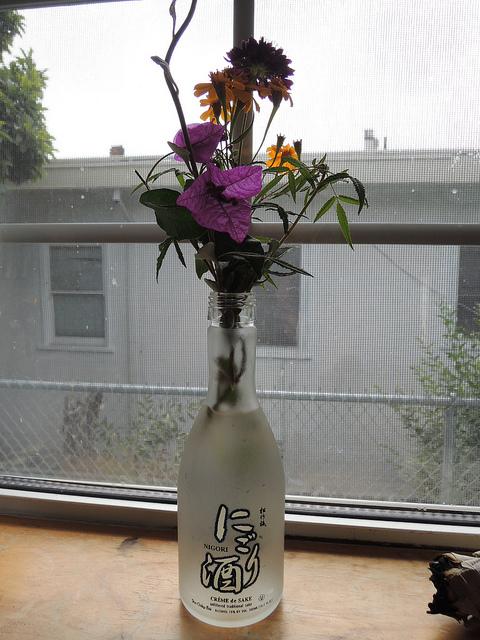Is this photo taken indoors?
Answer briefly. Yes. Is the bottle opaque?
Write a very short answer. Yes. What color is the flower?
Answer briefly. Purple. 